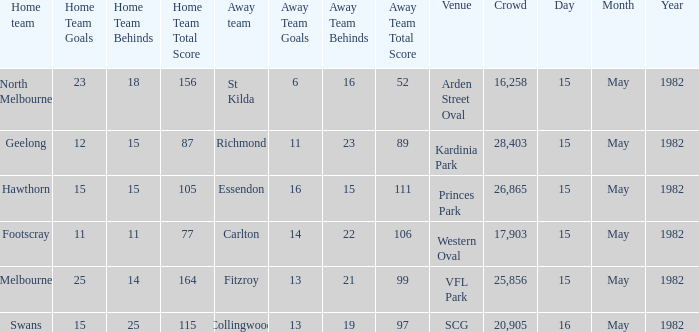Which away team had more than 17,903 spectators and played Melbourne? 13.21 (99). 